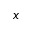Convert formula to latex. <formula><loc_0><loc_0><loc_500><loc_500>x</formula> 